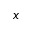Convert formula to latex. <formula><loc_0><loc_0><loc_500><loc_500>x</formula> 